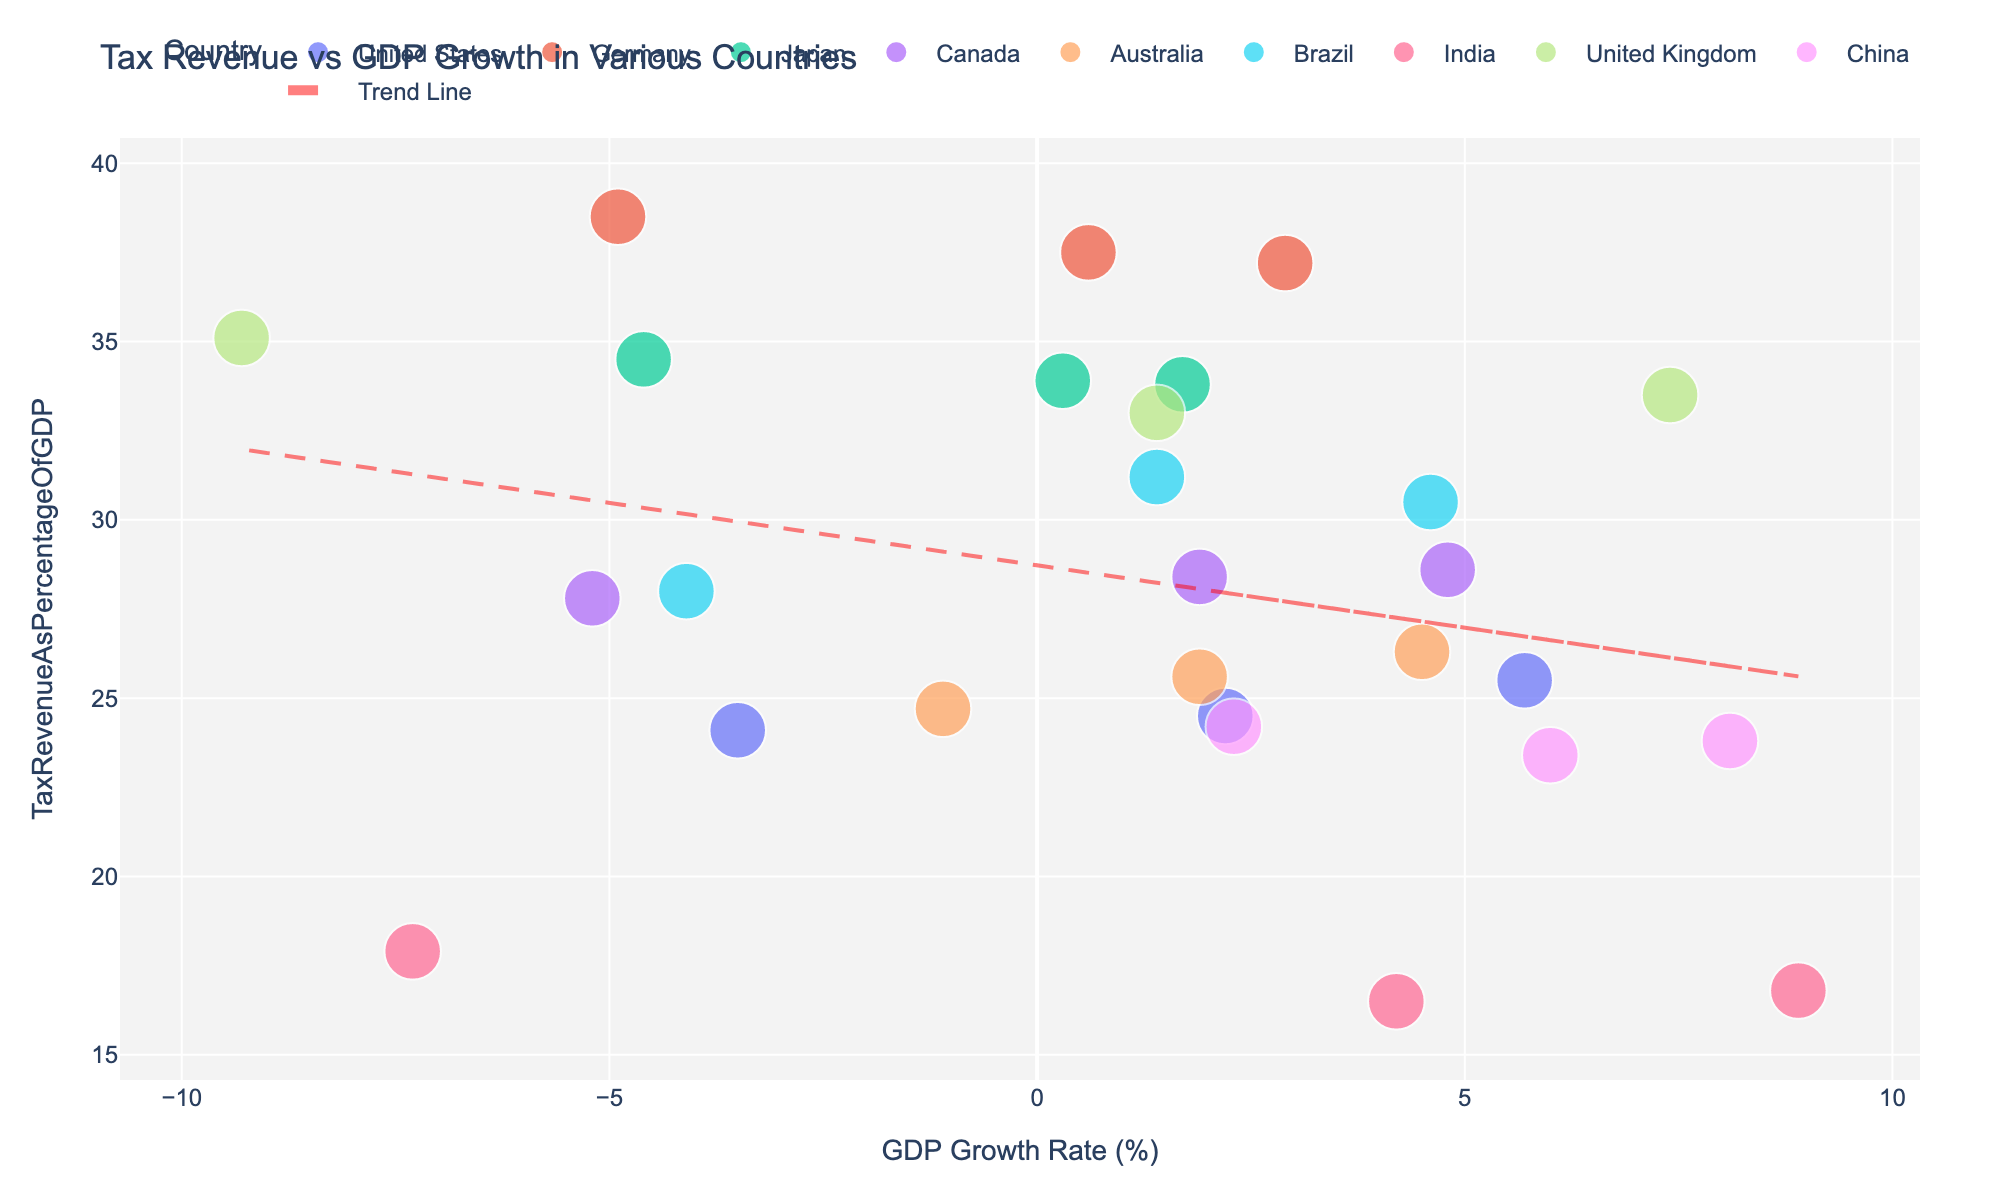What is the title of the scatter plot? The title is usually located at the top of the figure and it provides a brief summary of the plot. In this case, find the text at the top center of the plot.
Answer: Tax Revenue vs GDP Growth in Various Countries Which country has the highest tax revenue as a percentage of GDP in 2021? Locate the points for the year 2021 and compare the y-values, which represent the tax revenue as a percentage of GDP. The highest y-value will indicate the country with the highest tax revenue.
Answer: United States What trend does the trend line indicate about the relationship between GDP growth rate and tax revenue as a percentage of GDP? Observe the slope of the trend line. If it slopes upwards from left to right, it indicates a positive relationship; if it slopes downwards, it indicates a negative relationship.
Answer: Negative relationship Which country shows a drastic change in GDP growth rate from 2020 to 2021? Compare the x-values of data points for 2020 and 2021. The country with the largest difference in x-values between these years has the most drastic change.
Answer: India What is the tax revenue as a percentage of GDP for Brazil in 2019, and how does it compare to 2020? Locate the points for Brazil in 2019 and 2020 and compare their y-values. The point in 2019 has a higher y-value than in 2020.
Answer: 31.2% in 2019, higher than 28.0% in 2020 Which country had positive GDP growth in 2020 despite the pandemic? Identify the data point for the year 2020 with a positive x-value, which represents GDP growth.
Answer: China Which countries have data points that follow the overall trend indicated by the trend line? Determine which countries' data points approximately align with the trend line. Countries whose points are close to the line conform to the overall trend.
Answer: Germany, Japan, China Among the countries provided, which one experienced the least GDP growth in 2020? Compare the x-values of the data points for the year 2020. The point with the smallest x-value indicates the least GDP growth.
Answer: United Kingdom What is the range of tax revenue as a percentage of GDP for the countries in 2021? Identify the data points for 2021 and compare their y-values to find the minimum and maximum values. Subtract the minimum value from the maximum value to get the range.
Answer: 28.6% to 37.2%, range is 8.6% Do any countries have overlapping data points for the same year? Look closely at each year's data points to see if any two or more countries share the same x and y values.
Answer: No 